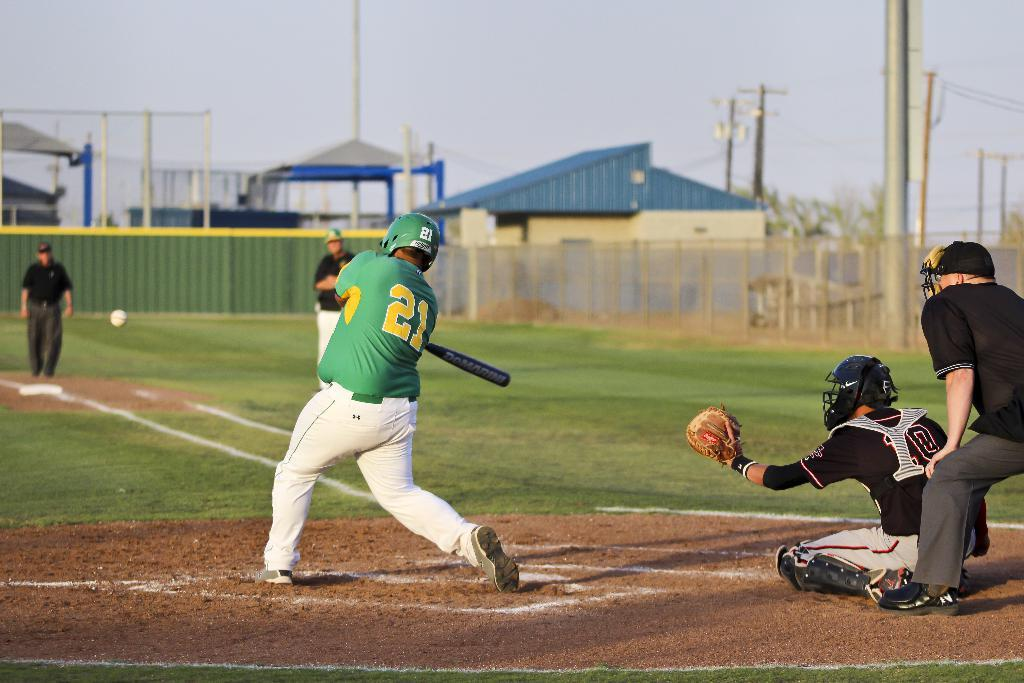How many people are on the ground in the image? There are five people on the ground in the image. What is happening with the ball in the image? The ball is in the air in the image. What type of surface is visible beneath the people and the ball? There is grass visible in the image. What objects are being used by the people in the image? There is a bat and helmets present in the image. What structures can be seen in the background of the image? There is a wall and a fence visible in the image. What type of vegetation is present in the image? Trees are present in the image. What type of buildings can be seen in the image? There are sheds in the image. What else can be seen in the image that hasn't been mentioned yet? There are some unspecified objects in the image. What is visible in the background of the image? The sky is visible in the background of the image. What type of quartz can be seen in the image? There is no quartz present in the image. What pump is being used by the people in the image? There is no pump present in the image. 